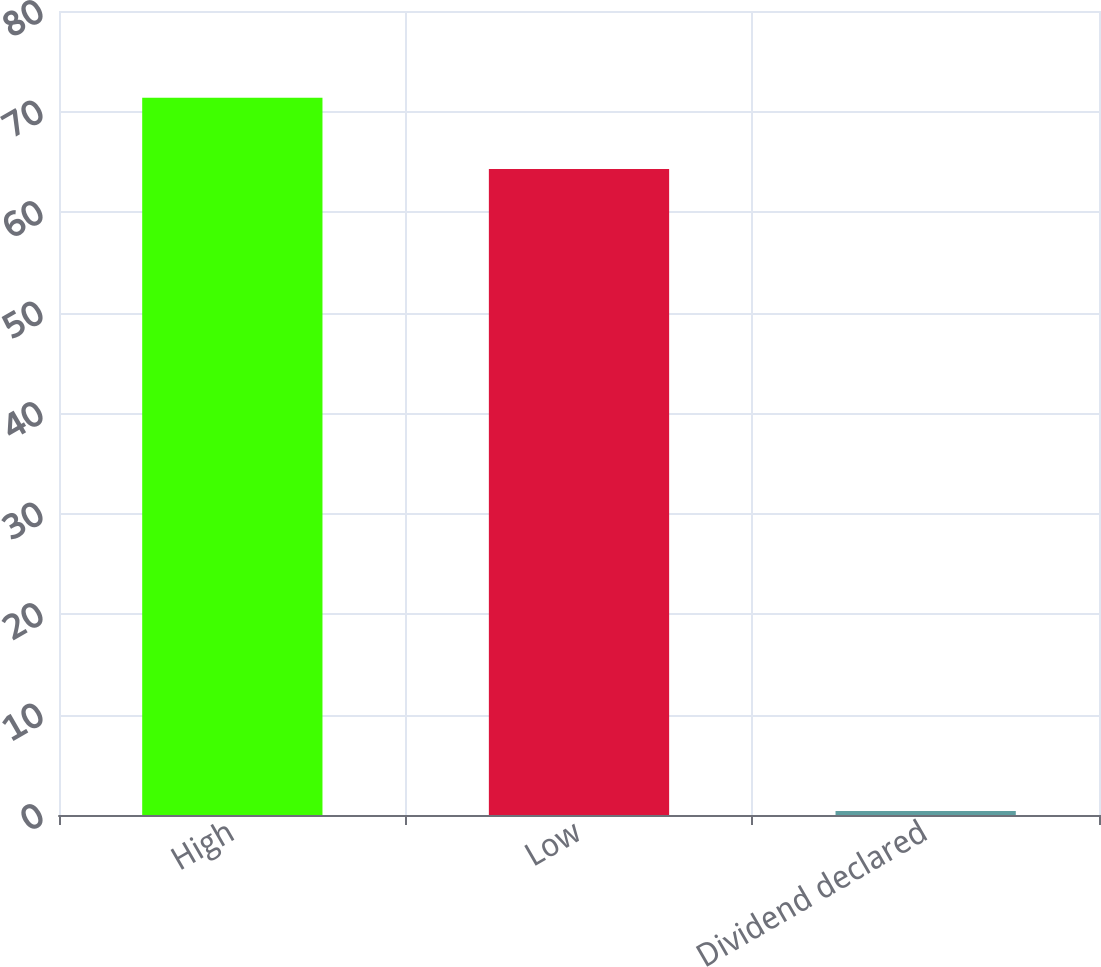Convert chart. <chart><loc_0><loc_0><loc_500><loc_500><bar_chart><fcel>High<fcel>Low<fcel>Dividend declared<nl><fcel>71.37<fcel>64.29<fcel>0.4<nl></chart> 